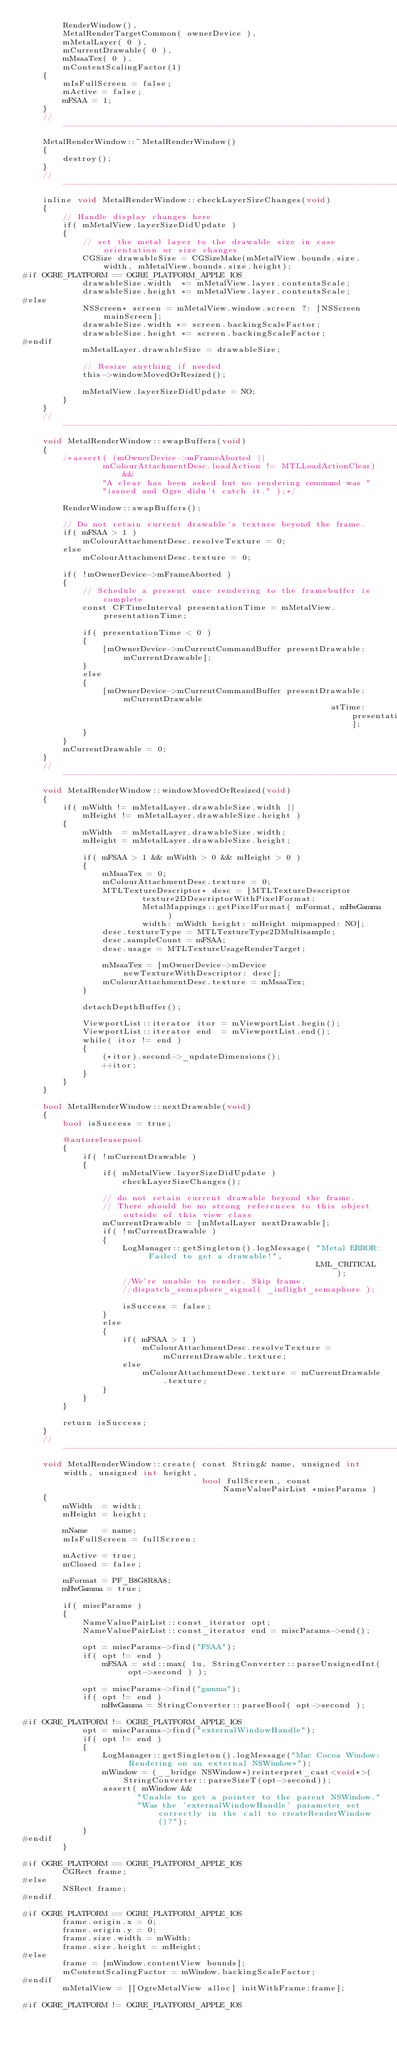<code> <loc_0><loc_0><loc_500><loc_500><_ObjectiveC_>        RenderWindow(),
        MetalRenderTargetCommon( ownerDevice ),
        mMetalLayer( 0 ),
        mCurrentDrawable( 0 ),
        mMsaaTex( 0 ),
        mContentScalingFactor(1)
    {
        mIsFullScreen = false;
        mActive = false;
        mFSAA = 1;
    }
    //-------------------------------------------------------------------------
    MetalRenderWindow::~MetalRenderWindow()
    {
        destroy();
    }
    //-------------------------------------------------------------------------
    inline void MetalRenderWindow::checkLayerSizeChanges(void)
    {
        // Handle display changes here
        if( mMetalView.layerSizeDidUpdate )
        {
            // set the metal layer to the drawable size in case orientation or size changes
            CGSize drawableSize = CGSizeMake(mMetalView.bounds.size.width, mMetalView.bounds.size.height);
#if OGRE_PLATFORM == OGRE_PLATFORM_APPLE_IOS
            drawableSize.width  *= mMetalView.layer.contentsScale;
            drawableSize.height *= mMetalView.layer.contentsScale;
#else
            NSScreen* screen = mMetalView.window.screen ?: [NSScreen mainScreen];
            drawableSize.width *= screen.backingScaleFactor;
            drawableSize.height *= screen.backingScaleFactor;
#endif
            mMetalLayer.drawableSize = drawableSize;

            // Resize anything if needed
            this->windowMovedOrResized();

            mMetalView.layerSizeDidUpdate = NO;
        }
    }
    //-------------------------------------------------------------------------
    void MetalRenderWindow::swapBuffers(void)
    {
        /*assert( (mOwnerDevice->mFrameAborted ||
                mColourAttachmentDesc.loadAction != MTLLoadActionClear) &&
                "A clear has been asked but no rendering command was "
                "issued and Ogre didn't catch it." );*/

        RenderWindow::swapBuffers();

        // Do not retain current drawable's texture beyond the frame.
        if( mFSAA > 1 )
            mColourAttachmentDesc.resolveTexture = 0;
        else
            mColourAttachmentDesc.texture = 0;

        if( !mOwnerDevice->mFrameAborted )
        {
            // Schedule a present once rendering to the framebuffer is complete
            const CFTimeInterval presentationTime = mMetalView.presentationTime;

            if( presentationTime < 0 )
            {
                [mOwnerDevice->mCurrentCommandBuffer presentDrawable:mCurrentDrawable];
            }
            else
            {
                [mOwnerDevice->mCurrentCommandBuffer presentDrawable:mCurrentDrawable
                                                              atTime:presentationTime];
            }
        }
        mCurrentDrawable = 0;
    }
    //-------------------------------------------------------------------------
    void MetalRenderWindow::windowMovedOrResized(void)
    {
        if( mWidth != mMetalLayer.drawableSize.width ||
            mHeight != mMetalLayer.drawableSize.height )
        {
            mWidth  = mMetalLayer.drawableSize.width;
            mHeight = mMetalLayer.drawableSize.height;

            if( mFSAA > 1 && mWidth > 0 && mHeight > 0 )
            {
                mMsaaTex = 0;
                mColourAttachmentDesc.texture = 0;
                MTLTextureDescriptor* desc = [MTLTextureDescriptor
                        texture2DDescriptorWithPixelFormat:
                        MetalMappings::getPixelFormat( mFormat, mHwGamma )
                        width: mWidth height: mHeight mipmapped: NO];
                desc.textureType = MTLTextureType2DMultisample;
                desc.sampleCount = mFSAA;
                desc.usage = MTLTextureUsageRenderTarget;

                mMsaaTex = [mOwnerDevice->mDevice newTextureWithDescriptor: desc];
                mColourAttachmentDesc.texture = mMsaaTex;
            }

            detachDepthBuffer();

            ViewportList::iterator itor = mViewportList.begin();
            ViewportList::iterator end  = mViewportList.end();
            while( itor != end )
            {
                (*itor).second->_updateDimensions();
                ++itor;
            }
        }
    }

    bool MetalRenderWindow::nextDrawable(void)
    {
        bool isSuccess = true;

        @autoreleasepool
        {
            if( !mCurrentDrawable )
            {
                if( mMetalView.layerSizeDidUpdate )
                    checkLayerSizeChanges();

                // do not retain current drawable beyond the frame.
                // There should be no strong references to this object outside of this view class
                mCurrentDrawable = [mMetalLayer nextDrawable];
                if( !mCurrentDrawable )
                {
                    LogManager::getSingleton().logMessage( "Metal ERROR: Failed to get a drawable!",
                                                           LML_CRITICAL );
                    //We're unable to render. Skip frame.
                    //dispatch_semaphore_signal( _inflight_semaphore );

                    isSuccess = false;
                }
                else
                {
                    if( mFSAA > 1 )
                        mColourAttachmentDesc.resolveTexture = mCurrentDrawable.texture;
                    else
                        mColourAttachmentDesc.texture = mCurrentDrawable.texture;
                }
            }
        }

        return isSuccess;
    }
    //-------------------------------------------------------------------------
    void MetalRenderWindow::create( const String& name, unsigned int width, unsigned int height,
                                    bool fullScreen, const NameValuePairList *miscParams )
    {
        mWidth  = width;
        mHeight = height;

        mName   = name;
        mIsFullScreen = fullScreen;

        mActive = true;
        mClosed = false;

        mFormat = PF_B8G8R8A8;
        mHwGamma = true;

        if( miscParams )
        {
            NameValuePairList::const_iterator opt;
            NameValuePairList::const_iterator end = miscParams->end();

            opt = miscParams->find("FSAA");
            if( opt != end )
                mFSAA = std::max( 1u, StringConverter::parseUnsignedInt( opt->second ) );

            opt = miscParams->find("gamma");
            if( opt != end )
                mHwGamma = StringConverter::parseBool( opt->second );

#if OGRE_PLATFORM != OGRE_PLATFORM_APPLE_IOS
            opt = miscParams->find("externalWindowHandle");
            if( opt != end )
            {
                LogManager::getSingleton().logMessage("Mac Cocoa Window: Rendering on an external NSWindow*");
                mWindow = (__bridge NSWindow*)reinterpret_cast<void*>(StringConverter::parseSizeT(opt->second));
                assert( mWindow &&
                       "Unable to get a pointer to the parent NSWindow."
                       "Was the 'externalWindowHandle' parameter set correctly in the call to createRenderWindow()?");
            }
#endif
        }

#if OGRE_PLATFORM == OGRE_PLATFORM_APPLE_IOS
        CGRect frame;
#else
        NSRect frame;
#endif

#if OGRE_PLATFORM == OGRE_PLATFORM_APPLE_IOS
        frame.origin.x = 0;
        frame.origin.y = 0;
        frame.size.width = mWidth;
        frame.size.height = mHeight;
#else
        frame = [mWindow.contentView bounds];
        mContentScalingFactor = mWindow.backingScaleFactor;
#endif
        mMetalView = [[OgreMetalView alloc] initWithFrame:frame];

#if OGRE_PLATFORM != OGRE_PLATFORM_APPLE_IOS</code> 